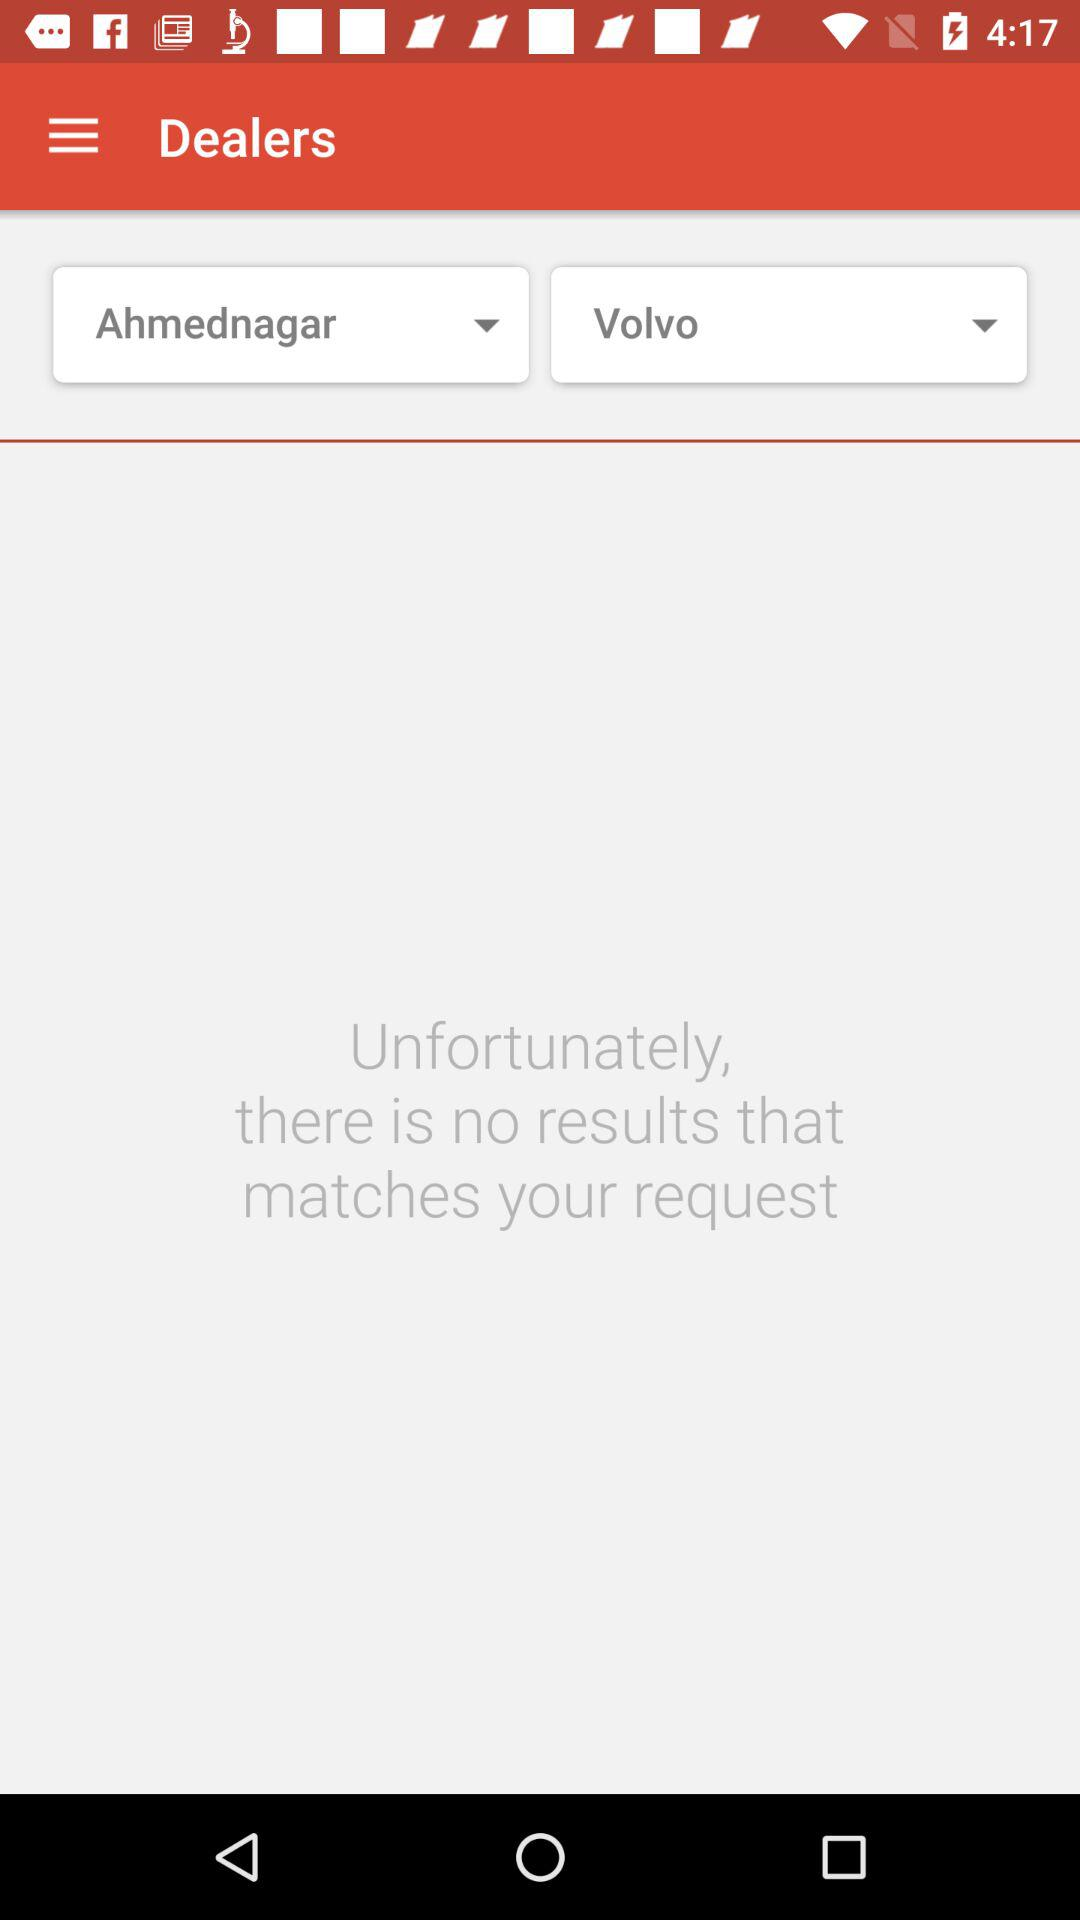What is the selected city? The selected city is Ahmednagar. 